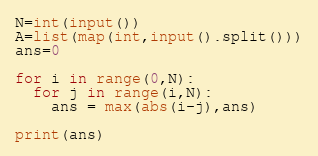Convert code to text. <code><loc_0><loc_0><loc_500><loc_500><_Python_>N=int(input())
A=list(map(int,input().split()))
ans=0

for i in range(0,N):
  for j in range(i,N):
    ans = max(abs(i-j),ans)
    
print(ans)</code> 